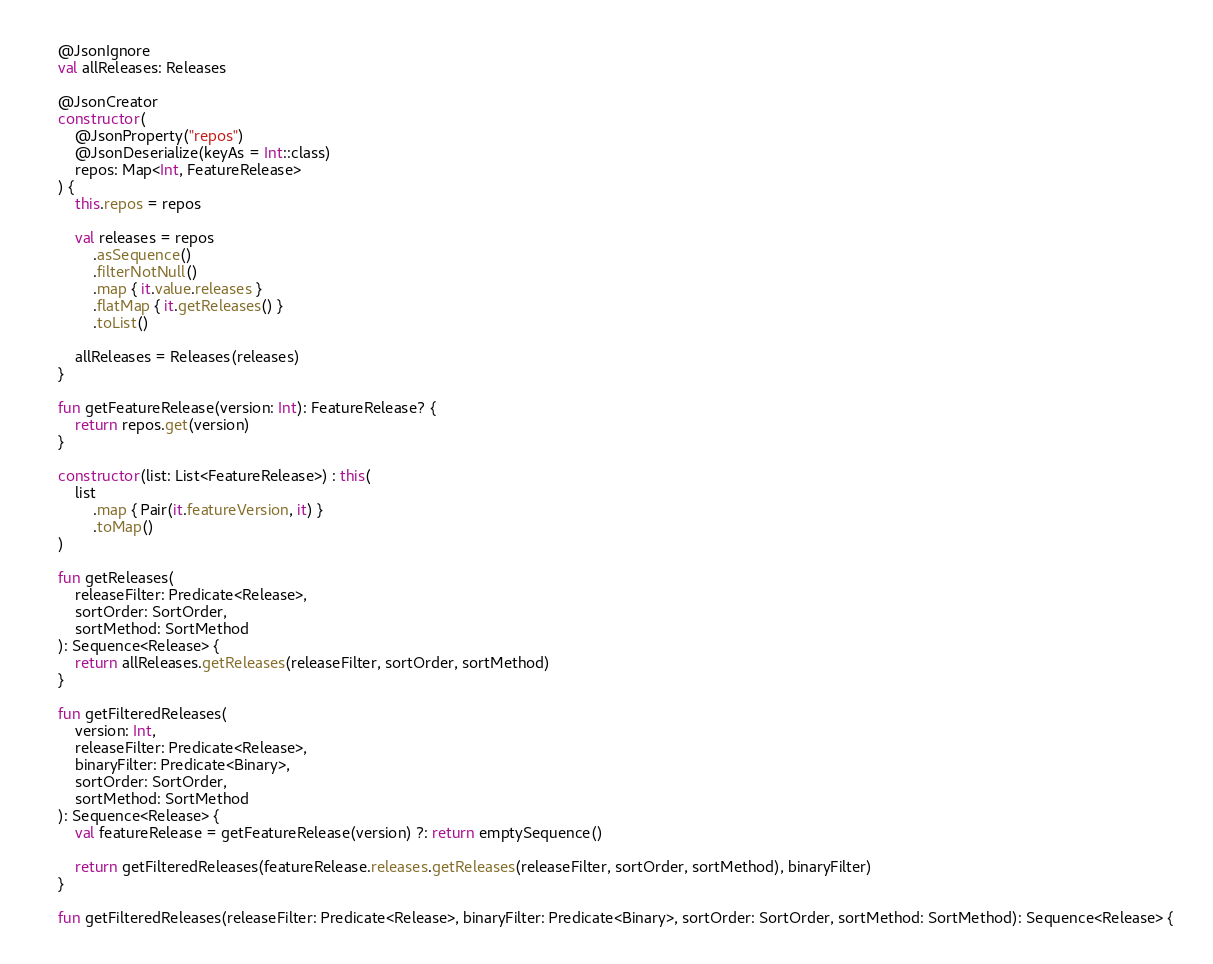<code> <loc_0><loc_0><loc_500><loc_500><_Kotlin_>    @JsonIgnore
    val allReleases: Releases

    @JsonCreator
    constructor(
        @JsonProperty("repos")
        @JsonDeserialize(keyAs = Int::class)
        repos: Map<Int, FeatureRelease>
    ) {
        this.repos = repos

        val releases = repos
            .asSequence()
            .filterNotNull()
            .map { it.value.releases }
            .flatMap { it.getReleases() }
            .toList()

        allReleases = Releases(releases)
    }

    fun getFeatureRelease(version: Int): FeatureRelease? {
        return repos.get(version)
    }

    constructor(list: List<FeatureRelease>) : this(
        list
            .map { Pair(it.featureVersion, it) }
            .toMap()
    )

    fun getReleases(
        releaseFilter: Predicate<Release>,
        sortOrder: SortOrder,
        sortMethod: SortMethod
    ): Sequence<Release> {
        return allReleases.getReleases(releaseFilter, sortOrder, sortMethod)
    }

    fun getFilteredReleases(
        version: Int,
        releaseFilter: Predicate<Release>,
        binaryFilter: Predicate<Binary>,
        sortOrder: SortOrder,
        sortMethod: SortMethod
    ): Sequence<Release> {
        val featureRelease = getFeatureRelease(version) ?: return emptySequence()

        return getFilteredReleases(featureRelease.releases.getReleases(releaseFilter, sortOrder, sortMethod), binaryFilter)
    }

    fun getFilteredReleases(releaseFilter: Predicate<Release>, binaryFilter: Predicate<Binary>, sortOrder: SortOrder, sortMethod: SortMethod): Sequence<Release> {</code> 